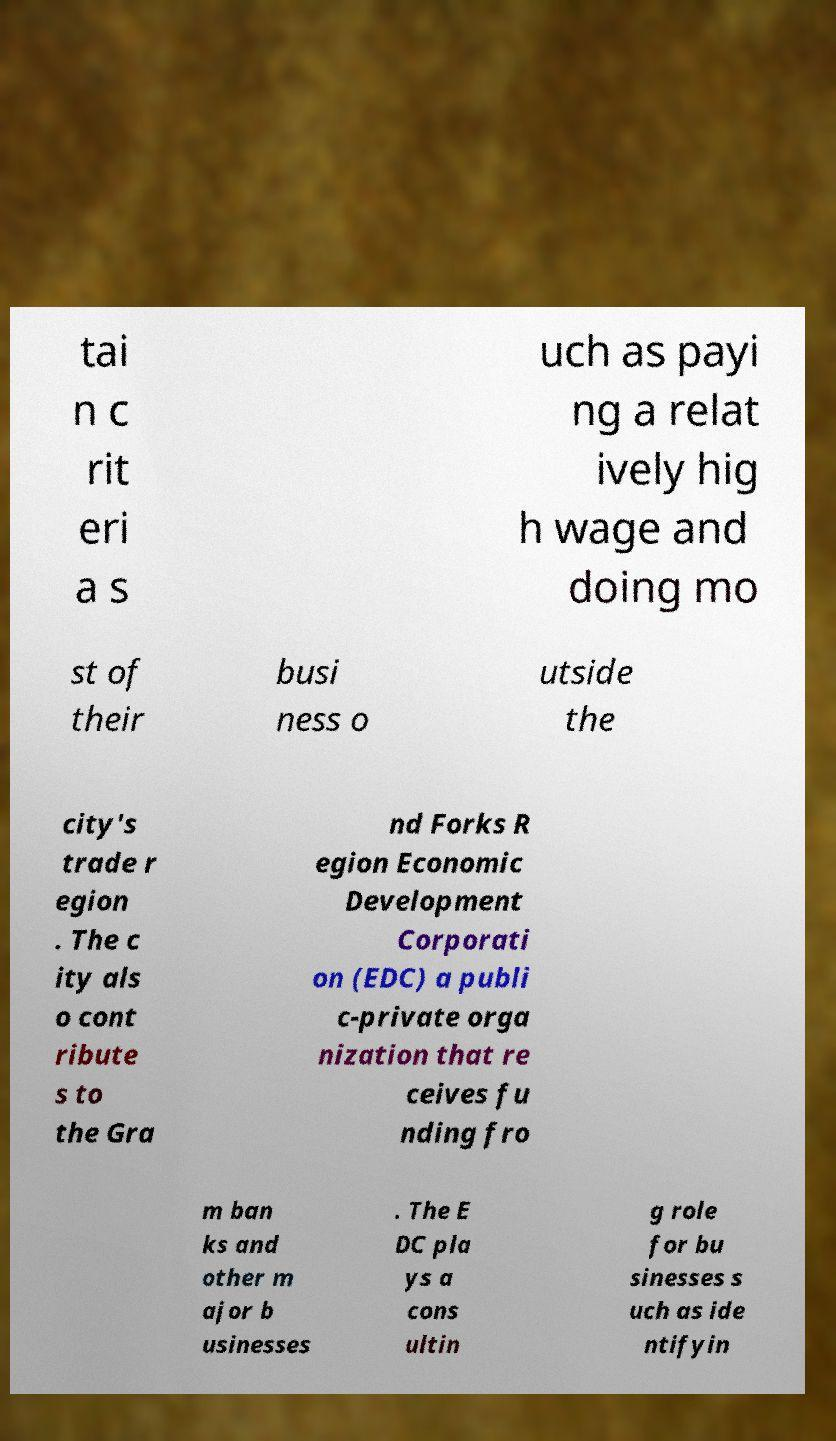Could you assist in decoding the text presented in this image and type it out clearly? tai n c rit eri a s uch as payi ng a relat ively hig h wage and doing mo st of their busi ness o utside the city's trade r egion . The c ity als o cont ribute s to the Gra nd Forks R egion Economic Development Corporati on (EDC) a publi c-private orga nization that re ceives fu nding fro m ban ks and other m ajor b usinesses . The E DC pla ys a cons ultin g role for bu sinesses s uch as ide ntifyin 